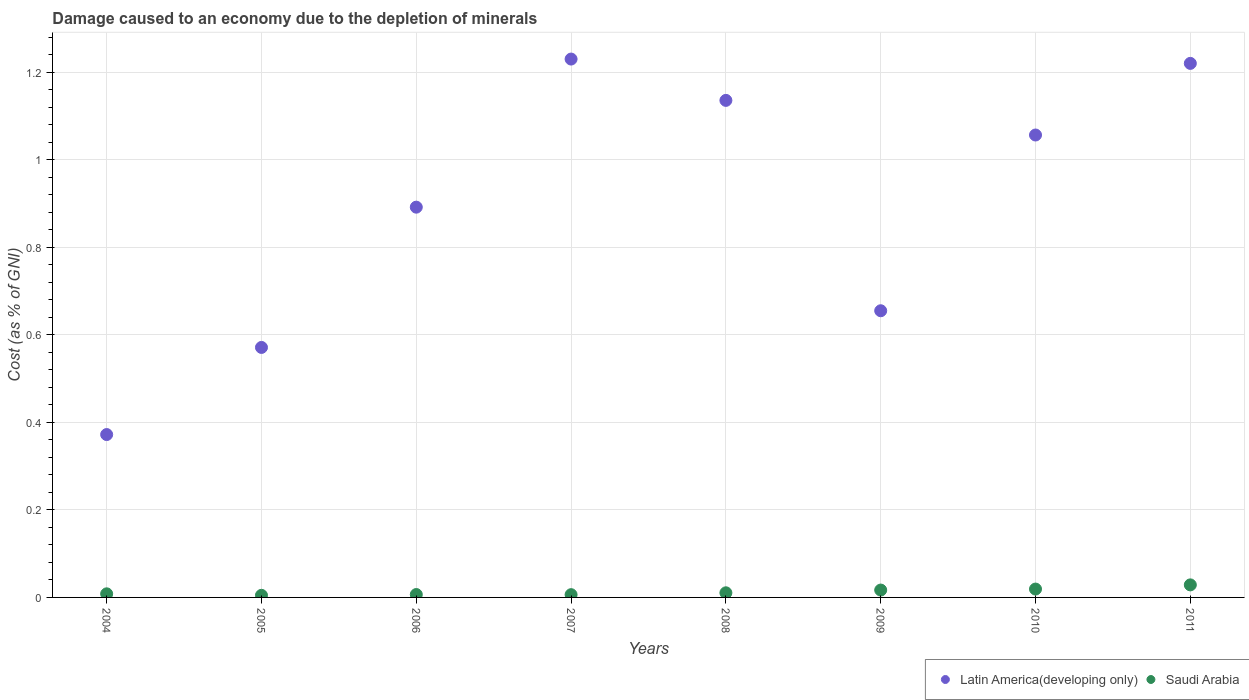How many different coloured dotlines are there?
Your answer should be very brief. 2. What is the cost of damage caused due to the depletion of minerals in Latin America(developing only) in 2008?
Keep it short and to the point. 1.14. Across all years, what is the maximum cost of damage caused due to the depletion of minerals in Latin America(developing only)?
Your response must be concise. 1.23. Across all years, what is the minimum cost of damage caused due to the depletion of minerals in Latin America(developing only)?
Offer a terse response. 0.37. In which year was the cost of damage caused due to the depletion of minerals in Latin America(developing only) maximum?
Make the answer very short. 2007. What is the total cost of damage caused due to the depletion of minerals in Latin America(developing only) in the graph?
Offer a very short reply. 7.13. What is the difference between the cost of damage caused due to the depletion of minerals in Latin America(developing only) in 2005 and that in 2008?
Your answer should be compact. -0.56. What is the difference between the cost of damage caused due to the depletion of minerals in Latin America(developing only) in 2007 and the cost of damage caused due to the depletion of minerals in Saudi Arabia in 2010?
Keep it short and to the point. 1.21. What is the average cost of damage caused due to the depletion of minerals in Latin America(developing only) per year?
Make the answer very short. 0.89. In the year 2007, what is the difference between the cost of damage caused due to the depletion of minerals in Latin America(developing only) and cost of damage caused due to the depletion of minerals in Saudi Arabia?
Your response must be concise. 1.22. What is the ratio of the cost of damage caused due to the depletion of minerals in Latin America(developing only) in 2007 to that in 2011?
Offer a very short reply. 1.01. Is the cost of damage caused due to the depletion of minerals in Latin America(developing only) in 2004 less than that in 2010?
Offer a very short reply. Yes. Is the difference between the cost of damage caused due to the depletion of minerals in Latin America(developing only) in 2005 and 2008 greater than the difference between the cost of damage caused due to the depletion of minerals in Saudi Arabia in 2005 and 2008?
Make the answer very short. No. What is the difference between the highest and the second highest cost of damage caused due to the depletion of minerals in Latin America(developing only)?
Offer a very short reply. 0.01. What is the difference between the highest and the lowest cost of damage caused due to the depletion of minerals in Saudi Arabia?
Make the answer very short. 0.02. Is the cost of damage caused due to the depletion of minerals in Latin America(developing only) strictly greater than the cost of damage caused due to the depletion of minerals in Saudi Arabia over the years?
Keep it short and to the point. Yes. Is the cost of damage caused due to the depletion of minerals in Latin America(developing only) strictly less than the cost of damage caused due to the depletion of minerals in Saudi Arabia over the years?
Provide a succinct answer. No. How many years are there in the graph?
Offer a terse response. 8. Are the values on the major ticks of Y-axis written in scientific E-notation?
Your response must be concise. No. Where does the legend appear in the graph?
Your answer should be compact. Bottom right. What is the title of the graph?
Provide a short and direct response. Damage caused to an economy due to the depletion of minerals. Does "Guinea-Bissau" appear as one of the legend labels in the graph?
Your answer should be very brief. No. What is the label or title of the X-axis?
Your response must be concise. Years. What is the label or title of the Y-axis?
Your response must be concise. Cost (as % of GNI). What is the Cost (as % of GNI) of Latin America(developing only) in 2004?
Give a very brief answer. 0.37. What is the Cost (as % of GNI) in Saudi Arabia in 2004?
Offer a terse response. 0.01. What is the Cost (as % of GNI) in Latin America(developing only) in 2005?
Your response must be concise. 0.57. What is the Cost (as % of GNI) of Saudi Arabia in 2005?
Offer a terse response. 0. What is the Cost (as % of GNI) in Latin America(developing only) in 2006?
Ensure brevity in your answer.  0.89. What is the Cost (as % of GNI) of Saudi Arabia in 2006?
Your response must be concise. 0.01. What is the Cost (as % of GNI) of Latin America(developing only) in 2007?
Your response must be concise. 1.23. What is the Cost (as % of GNI) in Saudi Arabia in 2007?
Provide a short and direct response. 0.01. What is the Cost (as % of GNI) in Latin America(developing only) in 2008?
Your answer should be very brief. 1.14. What is the Cost (as % of GNI) in Saudi Arabia in 2008?
Provide a short and direct response. 0.01. What is the Cost (as % of GNI) in Latin America(developing only) in 2009?
Ensure brevity in your answer.  0.66. What is the Cost (as % of GNI) in Saudi Arabia in 2009?
Your answer should be compact. 0.02. What is the Cost (as % of GNI) in Latin America(developing only) in 2010?
Your answer should be compact. 1.06. What is the Cost (as % of GNI) in Saudi Arabia in 2010?
Your answer should be compact. 0.02. What is the Cost (as % of GNI) of Latin America(developing only) in 2011?
Offer a terse response. 1.22. What is the Cost (as % of GNI) of Saudi Arabia in 2011?
Provide a short and direct response. 0.03. Across all years, what is the maximum Cost (as % of GNI) of Latin America(developing only)?
Provide a short and direct response. 1.23. Across all years, what is the maximum Cost (as % of GNI) of Saudi Arabia?
Offer a terse response. 0.03. Across all years, what is the minimum Cost (as % of GNI) in Latin America(developing only)?
Your answer should be very brief. 0.37. Across all years, what is the minimum Cost (as % of GNI) of Saudi Arabia?
Offer a very short reply. 0. What is the total Cost (as % of GNI) of Latin America(developing only) in the graph?
Offer a terse response. 7.13. What is the total Cost (as % of GNI) in Saudi Arabia in the graph?
Give a very brief answer. 0.1. What is the difference between the Cost (as % of GNI) of Latin America(developing only) in 2004 and that in 2005?
Your answer should be compact. -0.2. What is the difference between the Cost (as % of GNI) of Saudi Arabia in 2004 and that in 2005?
Give a very brief answer. 0. What is the difference between the Cost (as % of GNI) of Latin America(developing only) in 2004 and that in 2006?
Your response must be concise. -0.52. What is the difference between the Cost (as % of GNI) in Saudi Arabia in 2004 and that in 2006?
Your response must be concise. 0. What is the difference between the Cost (as % of GNI) of Latin America(developing only) in 2004 and that in 2007?
Ensure brevity in your answer.  -0.86. What is the difference between the Cost (as % of GNI) of Saudi Arabia in 2004 and that in 2007?
Provide a succinct answer. 0. What is the difference between the Cost (as % of GNI) in Latin America(developing only) in 2004 and that in 2008?
Offer a very short reply. -0.76. What is the difference between the Cost (as % of GNI) in Saudi Arabia in 2004 and that in 2008?
Offer a very short reply. -0. What is the difference between the Cost (as % of GNI) of Latin America(developing only) in 2004 and that in 2009?
Provide a short and direct response. -0.28. What is the difference between the Cost (as % of GNI) in Saudi Arabia in 2004 and that in 2009?
Provide a short and direct response. -0.01. What is the difference between the Cost (as % of GNI) in Latin America(developing only) in 2004 and that in 2010?
Offer a very short reply. -0.68. What is the difference between the Cost (as % of GNI) of Saudi Arabia in 2004 and that in 2010?
Offer a very short reply. -0.01. What is the difference between the Cost (as % of GNI) of Latin America(developing only) in 2004 and that in 2011?
Provide a succinct answer. -0.85. What is the difference between the Cost (as % of GNI) in Saudi Arabia in 2004 and that in 2011?
Your response must be concise. -0.02. What is the difference between the Cost (as % of GNI) in Latin America(developing only) in 2005 and that in 2006?
Keep it short and to the point. -0.32. What is the difference between the Cost (as % of GNI) of Saudi Arabia in 2005 and that in 2006?
Offer a terse response. -0. What is the difference between the Cost (as % of GNI) of Latin America(developing only) in 2005 and that in 2007?
Your response must be concise. -0.66. What is the difference between the Cost (as % of GNI) in Saudi Arabia in 2005 and that in 2007?
Give a very brief answer. -0. What is the difference between the Cost (as % of GNI) in Latin America(developing only) in 2005 and that in 2008?
Make the answer very short. -0.56. What is the difference between the Cost (as % of GNI) in Saudi Arabia in 2005 and that in 2008?
Offer a terse response. -0.01. What is the difference between the Cost (as % of GNI) of Latin America(developing only) in 2005 and that in 2009?
Your answer should be very brief. -0.08. What is the difference between the Cost (as % of GNI) of Saudi Arabia in 2005 and that in 2009?
Your response must be concise. -0.01. What is the difference between the Cost (as % of GNI) of Latin America(developing only) in 2005 and that in 2010?
Provide a short and direct response. -0.49. What is the difference between the Cost (as % of GNI) of Saudi Arabia in 2005 and that in 2010?
Provide a succinct answer. -0.01. What is the difference between the Cost (as % of GNI) of Latin America(developing only) in 2005 and that in 2011?
Your answer should be compact. -0.65. What is the difference between the Cost (as % of GNI) in Saudi Arabia in 2005 and that in 2011?
Make the answer very short. -0.02. What is the difference between the Cost (as % of GNI) of Latin America(developing only) in 2006 and that in 2007?
Your answer should be compact. -0.34. What is the difference between the Cost (as % of GNI) in Saudi Arabia in 2006 and that in 2007?
Your response must be concise. 0. What is the difference between the Cost (as % of GNI) of Latin America(developing only) in 2006 and that in 2008?
Make the answer very short. -0.24. What is the difference between the Cost (as % of GNI) of Saudi Arabia in 2006 and that in 2008?
Provide a short and direct response. -0. What is the difference between the Cost (as % of GNI) in Latin America(developing only) in 2006 and that in 2009?
Offer a very short reply. 0.24. What is the difference between the Cost (as % of GNI) of Saudi Arabia in 2006 and that in 2009?
Ensure brevity in your answer.  -0.01. What is the difference between the Cost (as % of GNI) in Latin America(developing only) in 2006 and that in 2010?
Offer a very short reply. -0.16. What is the difference between the Cost (as % of GNI) in Saudi Arabia in 2006 and that in 2010?
Your response must be concise. -0.01. What is the difference between the Cost (as % of GNI) of Latin America(developing only) in 2006 and that in 2011?
Keep it short and to the point. -0.33. What is the difference between the Cost (as % of GNI) of Saudi Arabia in 2006 and that in 2011?
Provide a succinct answer. -0.02. What is the difference between the Cost (as % of GNI) of Latin America(developing only) in 2007 and that in 2008?
Offer a terse response. 0.09. What is the difference between the Cost (as % of GNI) of Saudi Arabia in 2007 and that in 2008?
Offer a terse response. -0. What is the difference between the Cost (as % of GNI) in Latin America(developing only) in 2007 and that in 2009?
Your answer should be compact. 0.58. What is the difference between the Cost (as % of GNI) of Saudi Arabia in 2007 and that in 2009?
Make the answer very short. -0.01. What is the difference between the Cost (as % of GNI) of Latin America(developing only) in 2007 and that in 2010?
Your answer should be compact. 0.17. What is the difference between the Cost (as % of GNI) in Saudi Arabia in 2007 and that in 2010?
Provide a succinct answer. -0.01. What is the difference between the Cost (as % of GNI) of Latin America(developing only) in 2007 and that in 2011?
Ensure brevity in your answer.  0.01. What is the difference between the Cost (as % of GNI) in Saudi Arabia in 2007 and that in 2011?
Provide a short and direct response. -0.02. What is the difference between the Cost (as % of GNI) of Latin America(developing only) in 2008 and that in 2009?
Your answer should be compact. 0.48. What is the difference between the Cost (as % of GNI) of Saudi Arabia in 2008 and that in 2009?
Your answer should be very brief. -0.01. What is the difference between the Cost (as % of GNI) of Latin America(developing only) in 2008 and that in 2010?
Give a very brief answer. 0.08. What is the difference between the Cost (as % of GNI) in Saudi Arabia in 2008 and that in 2010?
Your answer should be compact. -0.01. What is the difference between the Cost (as % of GNI) of Latin America(developing only) in 2008 and that in 2011?
Offer a very short reply. -0.08. What is the difference between the Cost (as % of GNI) in Saudi Arabia in 2008 and that in 2011?
Offer a terse response. -0.02. What is the difference between the Cost (as % of GNI) in Latin America(developing only) in 2009 and that in 2010?
Offer a terse response. -0.4. What is the difference between the Cost (as % of GNI) of Saudi Arabia in 2009 and that in 2010?
Give a very brief answer. -0. What is the difference between the Cost (as % of GNI) in Latin America(developing only) in 2009 and that in 2011?
Make the answer very short. -0.57. What is the difference between the Cost (as % of GNI) in Saudi Arabia in 2009 and that in 2011?
Provide a succinct answer. -0.01. What is the difference between the Cost (as % of GNI) of Latin America(developing only) in 2010 and that in 2011?
Ensure brevity in your answer.  -0.16. What is the difference between the Cost (as % of GNI) in Saudi Arabia in 2010 and that in 2011?
Offer a very short reply. -0.01. What is the difference between the Cost (as % of GNI) of Latin America(developing only) in 2004 and the Cost (as % of GNI) of Saudi Arabia in 2005?
Provide a succinct answer. 0.37. What is the difference between the Cost (as % of GNI) in Latin America(developing only) in 2004 and the Cost (as % of GNI) in Saudi Arabia in 2006?
Keep it short and to the point. 0.37. What is the difference between the Cost (as % of GNI) of Latin America(developing only) in 2004 and the Cost (as % of GNI) of Saudi Arabia in 2007?
Offer a very short reply. 0.37. What is the difference between the Cost (as % of GNI) in Latin America(developing only) in 2004 and the Cost (as % of GNI) in Saudi Arabia in 2008?
Ensure brevity in your answer.  0.36. What is the difference between the Cost (as % of GNI) in Latin America(developing only) in 2004 and the Cost (as % of GNI) in Saudi Arabia in 2009?
Provide a succinct answer. 0.36. What is the difference between the Cost (as % of GNI) in Latin America(developing only) in 2004 and the Cost (as % of GNI) in Saudi Arabia in 2010?
Offer a very short reply. 0.35. What is the difference between the Cost (as % of GNI) of Latin America(developing only) in 2004 and the Cost (as % of GNI) of Saudi Arabia in 2011?
Provide a succinct answer. 0.34. What is the difference between the Cost (as % of GNI) in Latin America(developing only) in 2005 and the Cost (as % of GNI) in Saudi Arabia in 2006?
Your answer should be compact. 0.56. What is the difference between the Cost (as % of GNI) of Latin America(developing only) in 2005 and the Cost (as % of GNI) of Saudi Arabia in 2007?
Provide a succinct answer. 0.56. What is the difference between the Cost (as % of GNI) of Latin America(developing only) in 2005 and the Cost (as % of GNI) of Saudi Arabia in 2008?
Make the answer very short. 0.56. What is the difference between the Cost (as % of GNI) in Latin America(developing only) in 2005 and the Cost (as % of GNI) in Saudi Arabia in 2009?
Provide a succinct answer. 0.55. What is the difference between the Cost (as % of GNI) of Latin America(developing only) in 2005 and the Cost (as % of GNI) of Saudi Arabia in 2010?
Give a very brief answer. 0.55. What is the difference between the Cost (as % of GNI) of Latin America(developing only) in 2005 and the Cost (as % of GNI) of Saudi Arabia in 2011?
Offer a very short reply. 0.54. What is the difference between the Cost (as % of GNI) in Latin America(developing only) in 2006 and the Cost (as % of GNI) in Saudi Arabia in 2007?
Ensure brevity in your answer.  0.89. What is the difference between the Cost (as % of GNI) of Latin America(developing only) in 2006 and the Cost (as % of GNI) of Saudi Arabia in 2008?
Offer a terse response. 0.88. What is the difference between the Cost (as % of GNI) of Latin America(developing only) in 2006 and the Cost (as % of GNI) of Saudi Arabia in 2010?
Offer a terse response. 0.87. What is the difference between the Cost (as % of GNI) in Latin America(developing only) in 2006 and the Cost (as % of GNI) in Saudi Arabia in 2011?
Keep it short and to the point. 0.86. What is the difference between the Cost (as % of GNI) of Latin America(developing only) in 2007 and the Cost (as % of GNI) of Saudi Arabia in 2008?
Keep it short and to the point. 1.22. What is the difference between the Cost (as % of GNI) in Latin America(developing only) in 2007 and the Cost (as % of GNI) in Saudi Arabia in 2009?
Make the answer very short. 1.21. What is the difference between the Cost (as % of GNI) in Latin America(developing only) in 2007 and the Cost (as % of GNI) in Saudi Arabia in 2010?
Keep it short and to the point. 1.21. What is the difference between the Cost (as % of GNI) of Latin America(developing only) in 2007 and the Cost (as % of GNI) of Saudi Arabia in 2011?
Provide a short and direct response. 1.2. What is the difference between the Cost (as % of GNI) of Latin America(developing only) in 2008 and the Cost (as % of GNI) of Saudi Arabia in 2009?
Offer a terse response. 1.12. What is the difference between the Cost (as % of GNI) of Latin America(developing only) in 2008 and the Cost (as % of GNI) of Saudi Arabia in 2010?
Ensure brevity in your answer.  1.12. What is the difference between the Cost (as % of GNI) in Latin America(developing only) in 2008 and the Cost (as % of GNI) in Saudi Arabia in 2011?
Make the answer very short. 1.11. What is the difference between the Cost (as % of GNI) in Latin America(developing only) in 2009 and the Cost (as % of GNI) in Saudi Arabia in 2010?
Your response must be concise. 0.64. What is the difference between the Cost (as % of GNI) in Latin America(developing only) in 2009 and the Cost (as % of GNI) in Saudi Arabia in 2011?
Your response must be concise. 0.63. What is the difference between the Cost (as % of GNI) in Latin America(developing only) in 2010 and the Cost (as % of GNI) in Saudi Arabia in 2011?
Offer a terse response. 1.03. What is the average Cost (as % of GNI) in Latin America(developing only) per year?
Your answer should be compact. 0.89. What is the average Cost (as % of GNI) of Saudi Arabia per year?
Your response must be concise. 0.01. In the year 2004, what is the difference between the Cost (as % of GNI) in Latin America(developing only) and Cost (as % of GNI) in Saudi Arabia?
Keep it short and to the point. 0.36. In the year 2005, what is the difference between the Cost (as % of GNI) of Latin America(developing only) and Cost (as % of GNI) of Saudi Arabia?
Offer a terse response. 0.57. In the year 2006, what is the difference between the Cost (as % of GNI) in Latin America(developing only) and Cost (as % of GNI) in Saudi Arabia?
Provide a succinct answer. 0.89. In the year 2007, what is the difference between the Cost (as % of GNI) of Latin America(developing only) and Cost (as % of GNI) of Saudi Arabia?
Make the answer very short. 1.22. In the year 2008, what is the difference between the Cost (as % of GNI) in Latin America(developing only) and Cost (as % of GNI) in Saudi Arabia?
Provide a succinct answer. 1.13. In the year 2009, what is the difference between the Cost (as % of GNI) in Latin America(developing only) and Cost (as % of GNI) in Saudi Arabia?
Your response must be concise. 0.64. In the year 2010, what is the difference between the Cost (as % of GNI) of Latin America(developing only) and Cost (as % of GNI) of Saudi Arabia?
Make the answer very short. 1.04. In the year 2011, what is the difference between the Cost (as % of GNI) in Latin America(developing only) and Cost (as % of GNI) in Saudi Arabia?
Offer a very short reply. 1.19. What is the ratio of the Cost (as % of GNI) of Latin America(developing only) in 2004 to that in 2005?
Your answer should be compact. 0.65. What is the ratio of the Cost (as % of GNI) of Saudi Arabia in 2004 to that in 2005?
Your response must be concise. 1.72. What is the ratio of the Cost (as % of GNI) of Latin America(developing only) in 2004 to that in 2006?
Ensure brevity in your answer.  0.42. What is the ratio of the Cost (as % of GNI) of Saudi Arabia in 2004 to that in 2006?
Ensure brevity in your answer.  1.24. What is the ratio of the Cost (as % of GNI) in Latin America(developing only) in 2004 to that in 2007?
Offer a very short reply. 0.3. What is the ratio of the Cost (as % of GNI) in Saudi Arabia in 2004 to that in 2007?
Ensure brevity in your answer.  1.3. What is the ratio of the Cost (as % of GNI) in Latin America(developing only) in 2004 to that in 2008?
Your answer should be very brief. 0.33. What is the ratio of the Cost (as % of GNI) in Saudi Arabia in 2004 to that in 2008?
Offer a terse response. 0.78. What is the ratio of the Cost (as % of GNI) of Latin America(developing only) in 2004 to that in 2009?
Provide a succinct answer. 0.57. What is the ratio of the Cost (as % of GNI) of Saudi Arabia in 2004 to that in 2009?
Offer a very short reply. 0.49. What is the ratio of the Cost (as % of GNI) in Latin America(developing only) in 2004 to that in 2010?
Give a very brief answer. 0.35. What is the ratio of the Cost (as % of GNI) in Saudi Arabia in 2004 to that in 2010?
Keep it short and to the point. 0.43. What is the ratio of the Cost (as % of GNI) of Latin America(developing only) in 2004 to that in 2011?
Make the answer very short. 0.3. What is the ratio of the Cost (as % of GNI) in Saudi Arabia in 2004 to that in 2011?
Give a very brief answer. 0.29. What is the ratio of the Cost (as % of GNI) in Latin America(developing only) in 2005 to that in 2006?
Give a very brief answer. 0.64. What is the ratio of the Cost (as % of GNI) of Saudi Arabia in 2005 to that in 2006?
Provide a succinct answer. 0.72. What is the ratio of the Cost (as % of GNI) of Latin America(developing only) in 2005 to that in 2007?
Give a very brief answer. 0.46. What is the ratio of the Cost (as % of GNI) of Saudi Arabia in 2005 to that in 2007?
Ensure brevity in your answer.  0.76. What is the ratio of the Cost (as % of GNI) of Latin America(developing only) in 2005 to that in 2008?
Make the answer very short. 0.5. What is the ratio of the Cost (as % of GNI) in Saudi Arabia in 2005 to that in 2008?
Your answer should be very brief. 0.45. What is the ratio of the Cost (as % of GNI) of Latin America(developing only) in 2005 to that in 2009?
Keep it short and to the point. 0.87. What is the ratio of the Cost (as % of GNI) of Saudi Arabia in 2005 to that in 2009?
Offer a very short reply. 0.28. What is the ratio of the Cost (as % of GNI) of Latin America(developing only) in 2005 to that in 2010?
Keep it short and to the point. 0.54. What is the ratio of the Cost (as % of GNI) of Saudi Arabia in 2005 to that in 2010?
Keep it short and to the point. 0.25. What is the ratio of the Cost (as % of GNI) of Latin America(developing only) in 2005 to that in 2011?
Ensure brevity in your answer.  0.47. What is the ratio of the Cost (as % of GNI) in Saudi Arabia in 2005 to that in 2011?
Your answer should be very brief. 0.17. What is the ratio of the Cost (as % of GNI) of Latin America(developing only) in 2006 to that in 2007?
Make the answer very short. 0.72. What is the ratio of the Cost (as % of GNI) in Saudi Arabia in 2006 to that in 2007?
Your response must be concise. 1.05. What is the ratio of the Cost (as % of GNI) of Latin America(developing only) in 2006 to that in 2008?
Make the answer very short. 0.79. What is the ratio of the Cost (as % of GNI) of Saudi Arabia in 2006 to that in 2008?
Make the answer very short. 0.63. What is the ratio of the Cost (as % of GNI) of Latin America(developing only) in 2006 to that in 2009?
Offer a very short reply. 1.36. What is the ratio of the Cost (as % of GNI) of Saudi Arabia in 2006 to that in 2009?
Offer a terse response. 0.39. What is the ratio of the Cost (as % of GNI) in Latin America(developing only) in 2006 to that in 2010?
Keep it short and to the point. 0.84. What is the ratio of the Cost (as % of GNI) in Saudi Arabia in 2006 to that in 2010?
Offer a terse response. 0.35. What is the ratio of the Cost (as % of GNI) in Latin America(developing only) in 2006 to that in 2011?
Keep it short and to the point. 0.73. What is the ratio of the Cost (as % of GNI) in Saudi Arabia in 2006 to that in 2011?
Provide a short and direct response. 0.23. What is the ratio of the Cost (as % of GNI) of Latin America(developing only) in 2007 to that in 2008?
Give a very brief answer. 1.08. What is the ratio of the Cost (as % of GNI) of Saudi Arabia in 2007 to that in 2008?
Offer a very short reply. 0.6. What is the ratio of the Cost (as % of GNI) of Latin America(developing only) in 2007 to that in 2009?
Offer a very short reply. 1.88. What is the ratio of the Cost (as % of GNI) in Saudi Arabia in 2007 to that in 2009?
Your response must be concise. 0.37. What is the ratio of the Cost (as % of GNI) in Latin America(developing only) in 2007 to that in 2010?
Your answer should be very brief. 1.16. What is the ratio of the Cost (as % of GNI) of Saudi Arabia in 2007 to that in 2010?
Give a very brief answer. 0.33. What is the ratio of the Cost (as % of GNI) in Latin America(developing only) in 2007 to that in 2011?
Keep it short and to the point. 1.01. What is the ratio of the Cost (as % of GNI) of Saudi Arabia in 2007 to that in 2011?
Give a very brief answer. 0.22. What is the ratio of the Cost (as % of GNI) in Latin America(developing only) in 2008 to that in 2009?
Keep it short and to the point. 1.73. What is the ratio of the Cost (as % of GNI) in Saudi Arabia in 2008 to that in 2009?
Ensure brevity in your answer.  0.63. What is the ratio of the Cost (as % of GNI) of Latin America(developing only) in 2008 to that in 2010?
Your response must be concise. 1.07. What is the ratio of the Cost (as % of GNI) in Saudi Arabia in 2008 to that in 2010?
Provide a short and direct response. 0.55. What is the ratio of the Cost (as % of GNI) of Latin America(developing only) in 2008 to that in 2011?
Make the answer very short. 0.93. What is the ratio of the Cost (as % of GNI) in Saudi Arabia in 2008 to that in 2011?
Give a very brief answer. 0.37. What is the ratio of the Cost (as % of GNI) of Latin America(developing only) in 2009 to that in 2010?
Your answer should be very brief. 0.62. What is the ratio of the Cost (as % of GNI) in Saudi Arabia in 2009 to that in 2010?
Offer a terse response. 0.88. What is the ratio of the Cost (as % of GNI) of Latin America(developing only) in 2009 to that in 2011?
Your response must be concise. 0.54. What is the ratio of the Cost (as % of GNI) of Saudi Arabia in 2009 to that in 2011?
Offer a terse response. 0.59. What is the ratio of the Cost (as % of GNI) of Latin America(developing only) in 2010 to that in 2011?
Offer a terse response. 0.87. What is the ratio of the Cost (as % of GNI) of Saudi Arabia in 2010 to that in 2011?
Ensure brevity in your answer.  0.67. What is the difference between the highest and the second highest Cost (as % of GNI) in Latin America(developing only)?
Provide a short and direct response. 0.01. What is the difference between the highest and the second highest Cost (as % of GNI) of Saudi Arabia?
Offer a very short reply. 0.01. What is the difference between the highest and the lowest Cost (as % of GNI) in Latin America(developing only)?
Keep it short and to the point. 0.86. What is the difference between the highest and the lowest Cost (as % of GNI) of Saudi Arabia?
Provide a succinct answer. 0.02. 